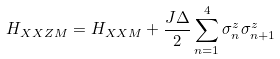<formula> <loc_0><loc_0><loc_500><loc_500>H _ { X X Z M } = H _ { X X M } + \frac { J \Delta } 2 \sum _ { n = 1 } ^ { 4 } \sigma _ { n } ^ { z } \sigma _ { n + 1 } ^ { z }</formula> 